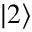<formula> <loc_0><loc_0><loc_500><loc_500>| 2 \rangle</formula> 